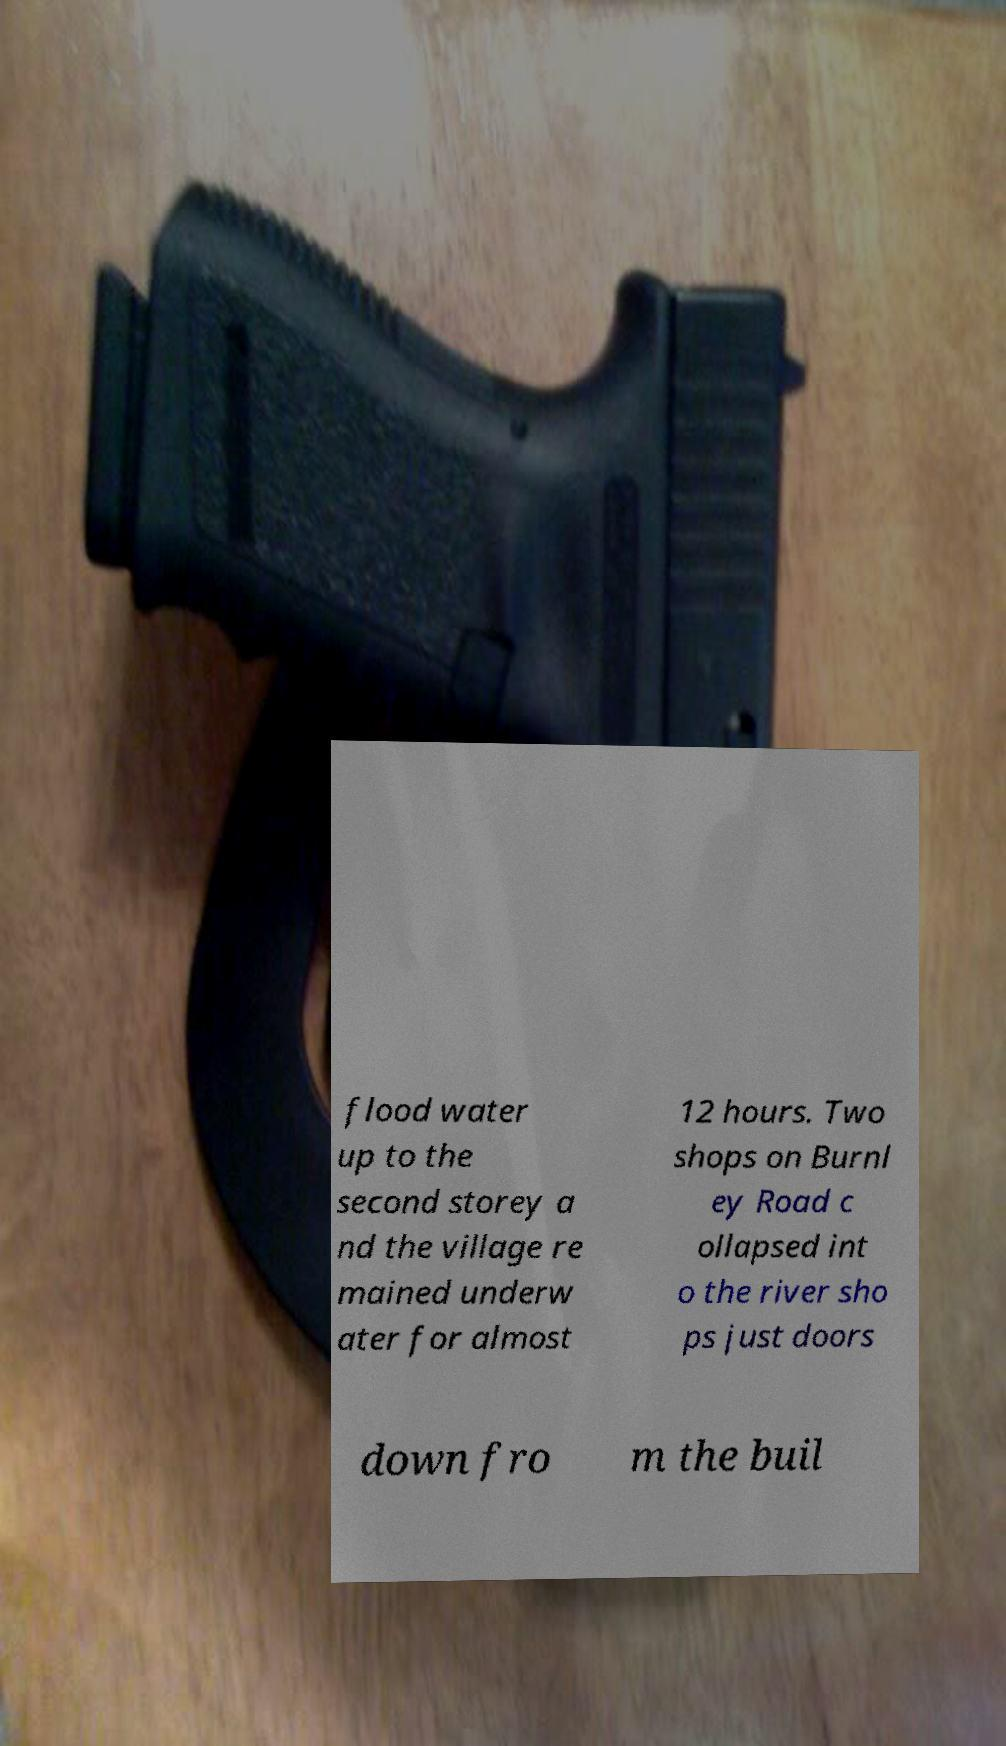Can you read and provide the text displayed in the image?This photo seems to have some interesting text. Can you extract and type it out for me? flood water up to the second storey a nd the village re mained underw ater for almost 12 hours. Two shops on Burnl ey Road c ollapsed int o the river sho ps just doors down fro m the buil 